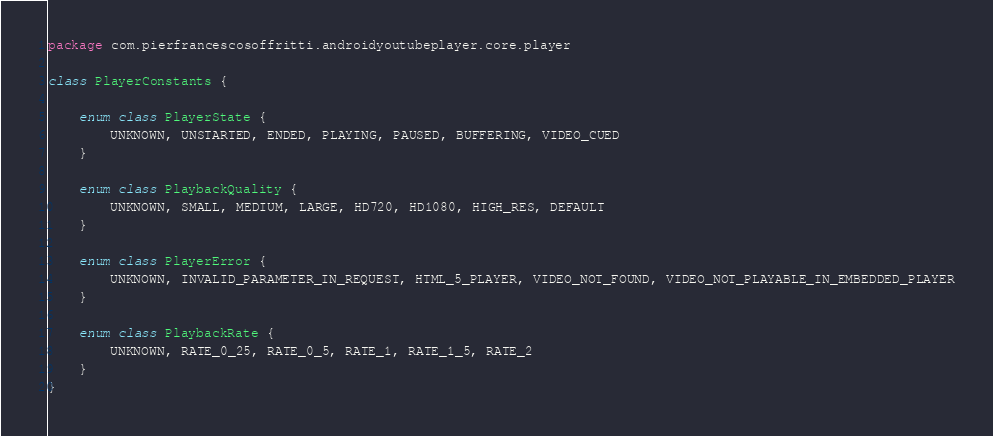Convert code to text. <code><loc_0><loc_0><loc_500><loc_500><_Kotlin_>package com.pierfrancescosoffritti.androidyoutubeplayer.core.player

class PlayerConstants {

    enum class PlayerState {
        UNKNOWN, UNSTARTED, ENDED, PLAYING, PAUSED, BUFFERING, VIDEO_CUED
    }

    enum class PlaybackQuality {
        UNKNOWN, SMALL, MEDIUM, LARGE, HD720, HD1080, HIGH_RES, DEFAULT
    }

    enum class PlayerError {
        UNKNOWN, INVALID_PARAMETER_IN_REQUEST, HTML_5_PLAYER, VIDEO_NOT_FOUND, VIDEO_NOT_PLAYABLE_IN_EMBEDDED_PLAYER
    }

    enum class PlaybackRate {
        UNKNOWN, RATE_0_25, RATE_0_5, RATE_1, RATE_1_5, RATE_2
    }
}</code> 